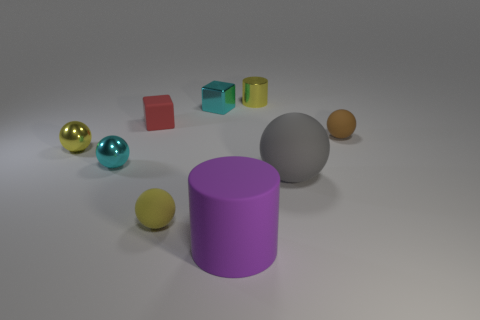Subtract all purple cylinders. How many yellow balls are left? 2 Subtract all large spheres. How many spheres are left? 4 Subtract all gray spheres. How many spheres are left? 4 Subtract all cyan balls. Subtract all cyan cylinders. How many balls are left? 4 Add 1 small green shiny balls. How many objects exist? 10 Subtract all blocks. How many objects are left? 7 Subtract 0 gray cylinders. How many objects are left? 9 Subtract all yellow rubber cylinders. Subtract all large balls. How many objects are left? 8 Add 7 yellow shiny objects. How many yellow shiny objects are left? 9 Add 5 tiny cyan spheres. How many tiny cyan spheres exist? 6 